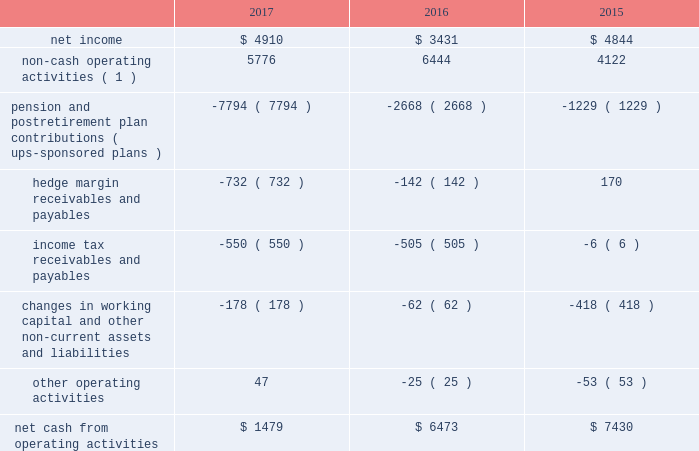United parcel service , inc .
And subsidiaries management's discussion and analysis of financial condition and results of operations liquidity and capital resources as of december 31 , 2017 , we had $ 4.069 billion in cash , cash equivalents and marketable securities .
We believe that our current cash position , access to the long-term debt capital markets and cash flow generated from operations should be adequate not only for operating requirements but also to enable us to complete our capital expenditure programs and to fund dividend payments , share repurchases and long-term debt payments through the next several years .
In addition , we have funds available from our commercial paper program and the ability to obtain alternative sources of financing .
We regularly evaluate opportunities to optimize our capital structure , including through issuances of debt to refinance existing debt and to fund ongoing cash needs .
Cash flows from operating activities the following is a summary of the significant sources ( uses ) of cash from operating activities ( amounts in millions ) : .
( 1 ) represents depreciation and amortization , gains and losses on derivative transactions and foreign exchange , deferred income taxes , provisions for uncollectible accounts , pension and postretirement benefit expense , stock compensation expense and other non-cash items .
Cash from operating activities remained strong throughout 2015 to 2017 .
Most of the variability in operating cash flows during the 2015 to 2017 time period relates to the funding of our company-sponsored pension and postretirement benefit plans ( and related cash tax deductions ) .
Except for discretionary or accelerated fundings of our plans , contributions to our company- sponsored pension plans have largely varied based on whether any minimum funding requirements are present for individual pension plans .
2022 we made discretionary contributions to our three primary company-sponsored u.s .
Pension plans totaling $ 7.291 , $ 2.461 and $ 1.030 billion in 2017 , 2016 and 2015 , respectively .
2022 the remaining contributions from 2015 to 2017 were largely due to contributions to our international pension plans and u.s .
Postretirement medical benefit plans .
Apart from the transactions described above , operating cash flow was impacted by changes in our working capital position , payments for income taxes and changes in hedge margin payables and receivables .
Cash payments for income taxes were $ 1.559 , $ 2.064 and $ 1.913 billion for 2017 , 2016 and 2015 , respectively , and were primarily impacted by the timing of current tax deductions .
The net hedge margin collateral ( paid ) /received from derivative counterparties was $ ( 732 ) , $ ( 142 ) and $ 170 million during 2017 , 2016 and 2015 , respectively , due to settlements and changes in the fair value of the derivative contracts used in our currency and interest rate hedging programs .
As of december 31 , 2017 , the total of our worldwide holdings of cash , cash equivalents and marketable securities were $ 4.069 billion , of which approximately $ 1.800 billion was held by foreign subsidiaries .
The amount of cash , cash equivalents and marketable securities held by our u.s .
And foreign subsidiaries fluctuates throughout the year due to a variety of factors , including the timing of cash receipts and disbursements in the normal course of business .
Cash provided by operating activities in the u.s .
Continues to be our primary source of funds to finance domestic operating needs , capital expenditures , share repurchases and dividend payments to shareowners .
As a result of the tax act , all cash , cash equivalents and marketable securities held by foreign subsidiaries are generally available for distribution to the u.s .
Without any u.s .
Federal income taxes .
Any such distributions may be subject to foreign withholding and u.s .
State taxes .
When amounts earned by foreign subsidiaries are expected to be indefinitely reinvested , no accrual for taxes is provided. .
What was the percentage change in pension and postretirement plan contributions ( ups-sponsored plans ) from 2015 to 2016? 
Rationale: this points to a large increase in pension liabilities and can be a going forward drain on operating cash .
Computations: ((2668 - 1229) / 1229)
Answer: 1.17087. 